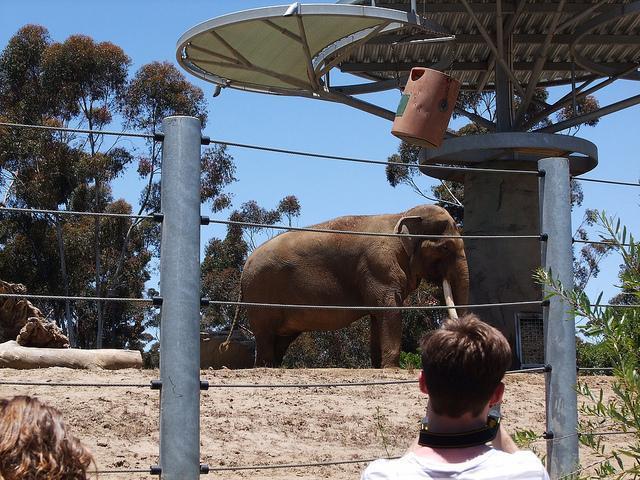How many people can be seen?
Give a very brief answer. 2. How many red train carts can you see?
Give a very brief answer. 0. 